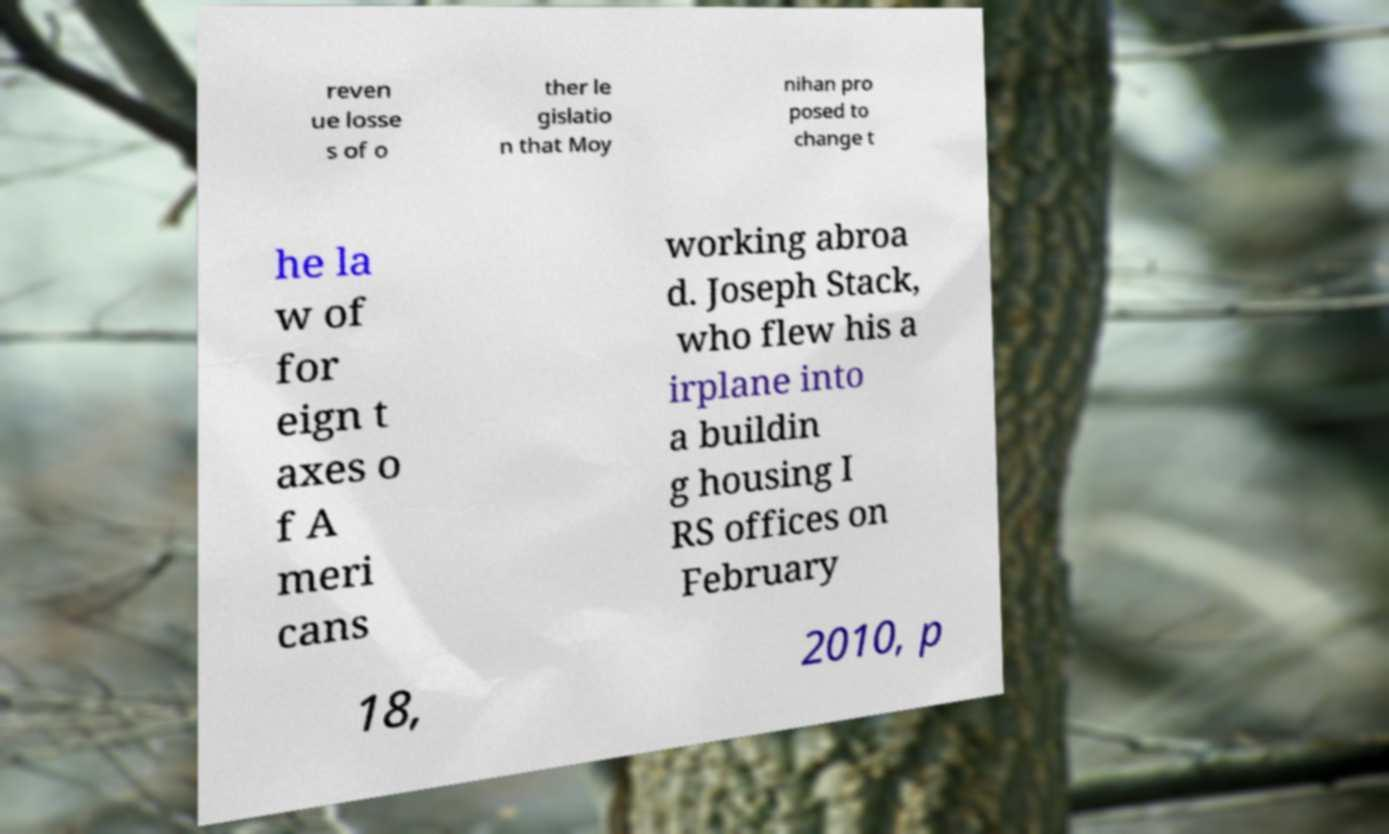There's text embedded in this image that I need extracted. Can you transcribe it verbatim? reven ue losse s of o ther le gislatio n that Moy nihan pro posed to change t he la w of for eign t axes o f A meri cans working abroa d. Joseph Stack, who flew his a irplane into a buildin g housing I RS offices on February 18, 2010, p 